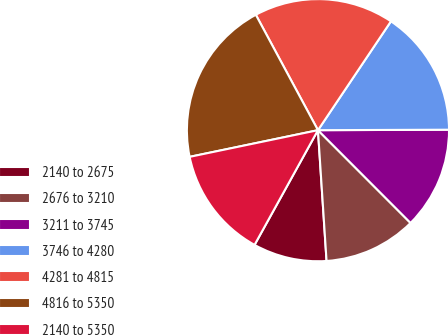<chart> <loc_0><loc_0><loc_500><loc_500><pie_chart><fcel>2140 to 2675<fcel>2676 to 3210<fcel>3211 to 3745<fcel>3746 to 4280<fcel>4281 to 4815<fcel>4816 to 5350<fcel>2140 to 5350<nl><fcel>9.08%<fcel>11.44%<fcel>12.57%<fcel>15.54%<fcel>17.26%<fcel>20.4%<fcel>13.7%<nl></chart> 